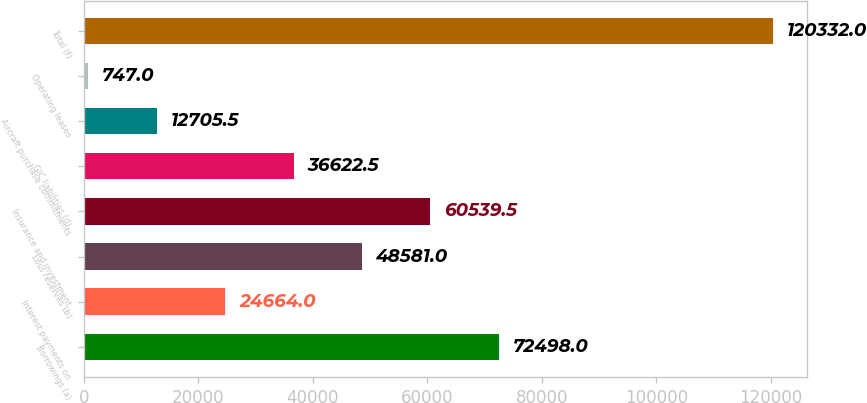<chart> <loc_0><loc_0><loc_500><loc_500><bar_chart><fcel>Borrowings (a)<fcel>Interest payments on<fcel>Loss reserves (b)<fcel>Insurance and investment<fcel>GIC liabilities (d)<fcel>Aircraft purchase commitments<fcel>Operating leases<fcel>Total (f)<nl><fcel>72498<fcel>24664<fcel>48581<fcel>60539.5<fcel>36622.5<fcel>12705.5<fcel>747<fcel>120332<nl></chart> 